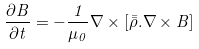<formula> <loc_0><loc_0><loc_500><loc_500>\frac { \partial B } { \partial t } = - \frac { 1 } { \mu _ { 0 } } \nabla \times [ \bar { \bar { \rho } } . \nabla \times B ]</formula> 